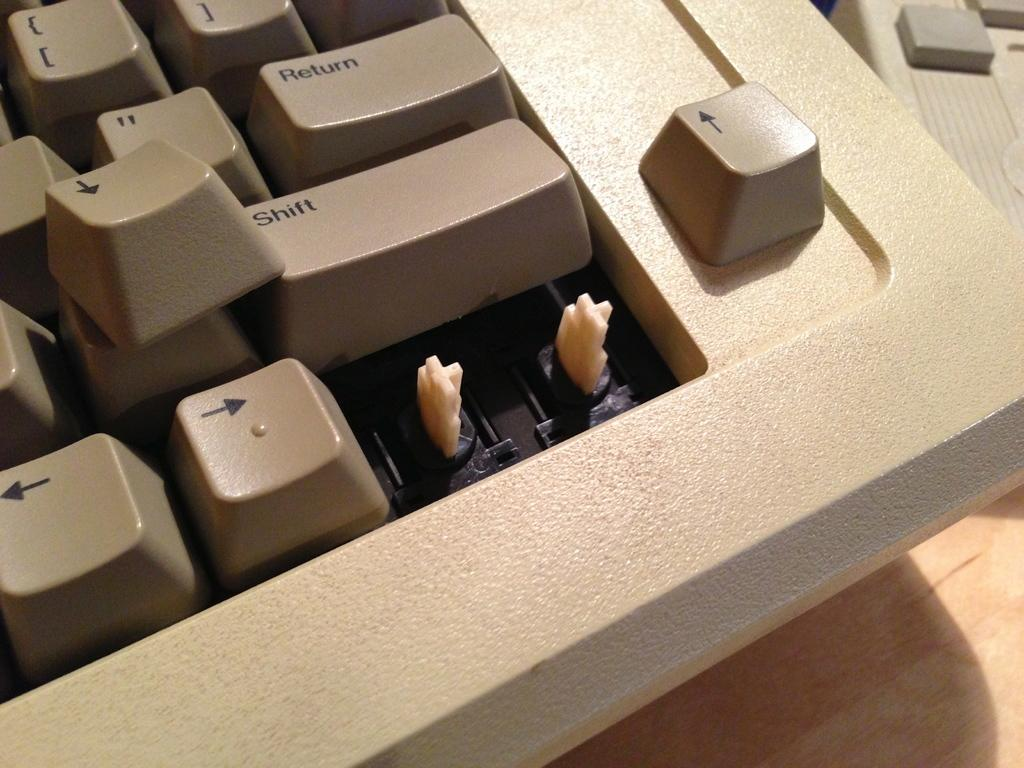<image>
Offer a succinct explanation of the picture presented. Computer keyboard with a Shift key under the Return key. 